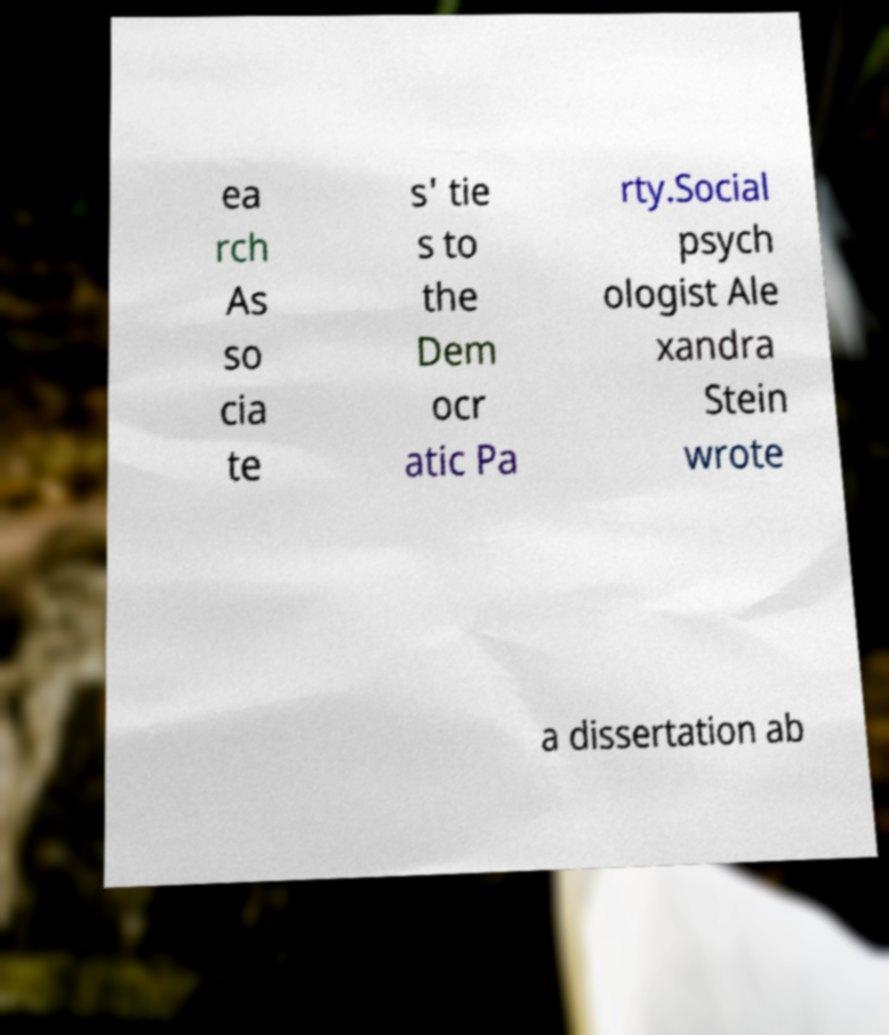What messages or text are displayed in this image? I need them in a readable, typed format. ea rch As so cia te s' tie s to the Dem ocr atic Pa rty.Social psych ologist Ale xandra Stein wrote a dissertation ab 